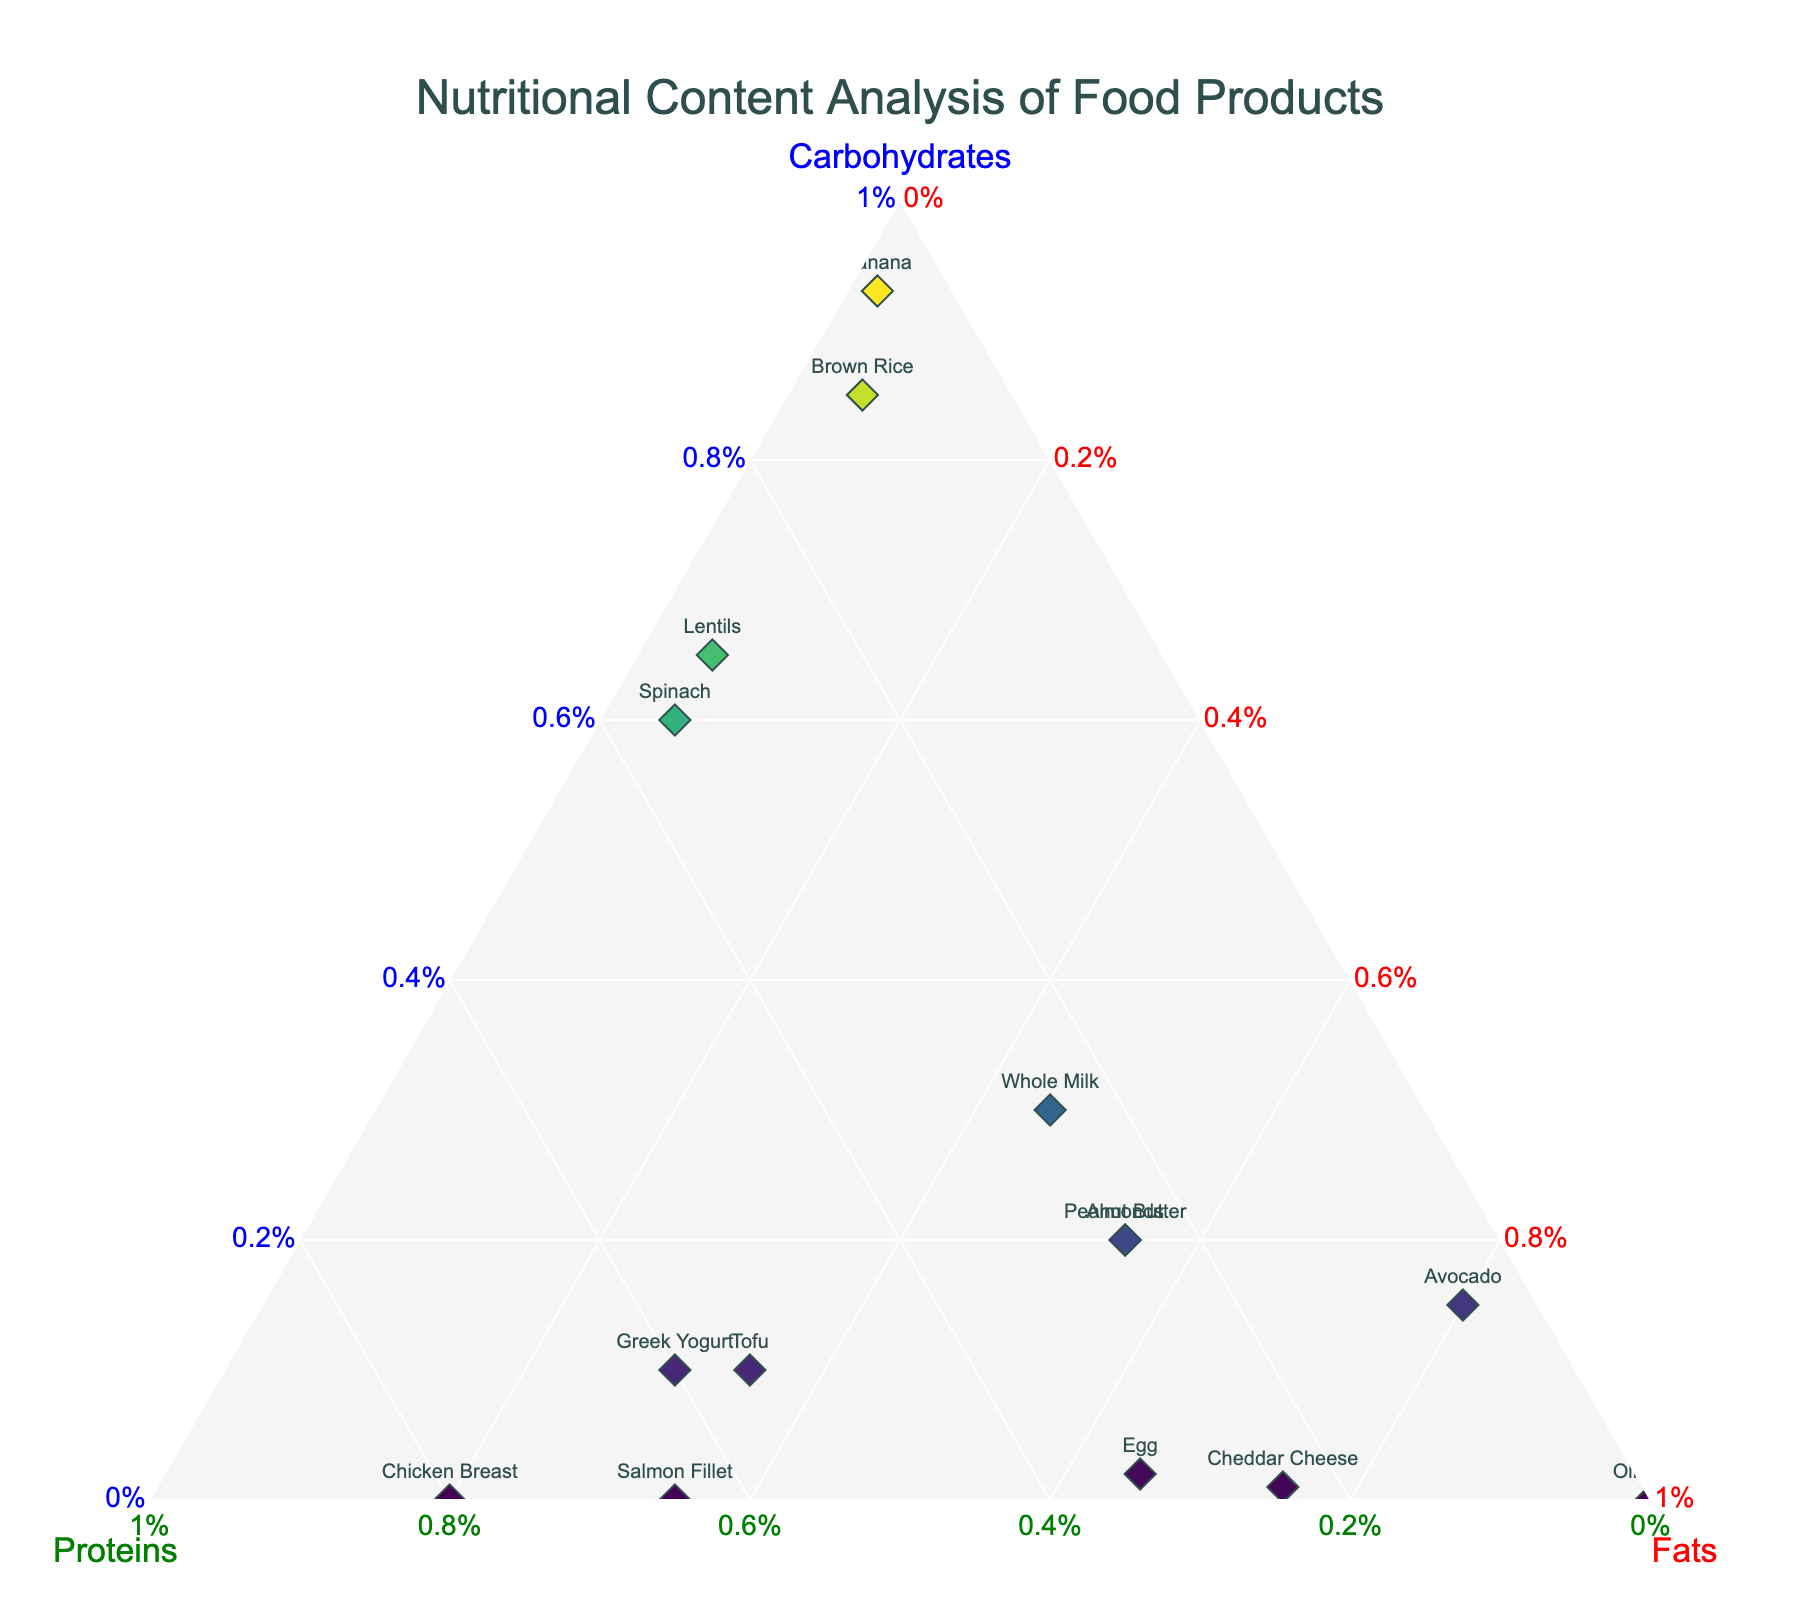What is the title of the plot? Look at the top center of the plot where the title is located. The title provides a brief description of what the plot represents.
Answer: Nutritional Content Analysis of Food Products What are the three macronutrients analyzed on the ternary plot? The plot uses three axes labeled with the names of the macronutrients. These axes are positioned at the corners of the triangle.
Answer: Carbohydrates, Proteins, Fats Which food product has the highest proportion of fats? Locate the food product that is closest to the 'Fats' corner of the ternary plot triangle.
Answer: Olive Oil How many food products have more than 50% carbohydrates? Check the positions of the food products and identify those that are located closer to the 'Carbohydrates' corner, with more than 50% proportion in carbohydrates.
Answer: 4 (Brown Rice, Lentils, Banana, Spinach) Which food product has an equal proportion of carbohydrates and proteins? Find the food product that is situated along the line that divides the triangle into two equal parts for carbohydrates and proteins.
Answer: Greek Yogurt What is the average proportion of proteins among Avocado, Chicken Breast, and Salmon Fillet? Check the representation of each food item for proteins and calculate the average: (0.05 + 0.80 + 0.65)/3.
Answer: 0.50 Which food product has a carbohydrate to protein ratio closest to 1:1? Identify the food product whose position indicates approximately equal proportions of carbohydrates and proteins.
Answer: Greek Yogurt Which two food products lie closest to each other on the ternary plot? Locate the two food products that are positioned near to each other and have similar proportions of carbohydrates, proteins, and fats.
Answer: Almonds and Peanut Butter How does Greek Yogurt compare with Cheddar Cheese in terms of protein content? Compare the positions of Greek Yogurt and Cheddar Cheese along the protein axis to see which has a higher proportion. Greek Yogurt has more.
Answer: Greek Yogurt has more protein than Cheddar Cheese What is the proportion of fats in Eggs? Look at the position of Eggs on the ternary plot and interpret its distance from the Fats corner.
Answer: 65% 